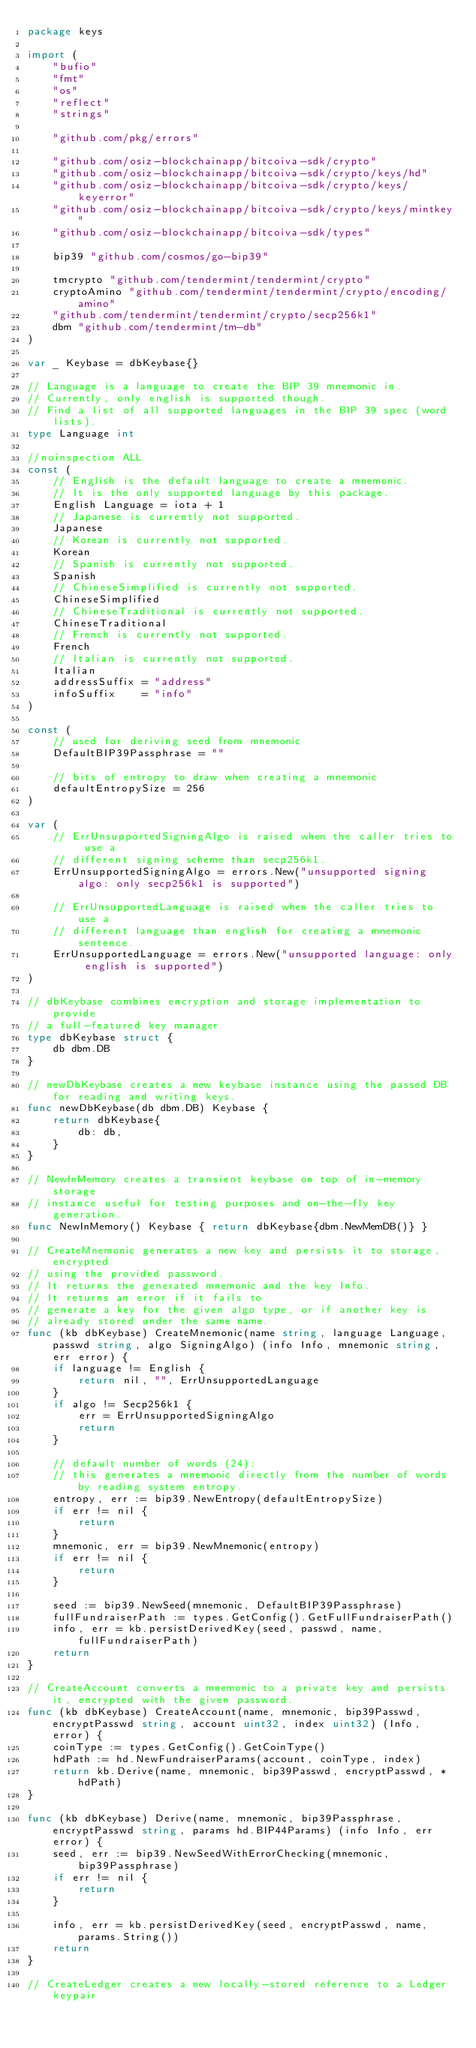<code> <loc_0><loc_0><loc_500><loc_500><_Go_>package keys

import (
	"bufio"
	"fmt"
	"os"
	"reflect"
	"strings"

	"github.com/pkg/errors"

	"github.com/osiz-blockchainapp/bitcoiva-sdk/crypto"
	"github.com/osiz-blockchainapp/bitcoiva-sdk/crypto/keys/hd"
	"github.com/osiz-blockchainapp/bitcoiva-sdk/crypto/keys/keyerror"
	"github.com/osiz-blockchainapp/bitcoiva-sdk/crypto/keys/mintkey"
	"github.com/osiz-blockchainapp/bitcoiva-sdk/types"

	bip39 "github.com/cosmos/go-bip39"

	tmcrypto "github.com/tendermint/tendermint/crypto"
	cryptoAmino "github.com/tendermint/tendermint/crypto/encoding/amino"
	"github.com/tendermint/tendermint/crypto/secp256k1"
	dbm "github.com/tendermint/tm-db"
)

var _ Keybase = dbKeybase{}

// Language is a language to create the BIP 39 mnemonic in.
// Currently, only english is supported though.
// Find a list of all supported languages in the BIP 39 spec (word lists).
type Language int

//noinspection ALL
const (
	// English is the default language to create a mnemonic.
	// It is the only supported language by this package.
	English Language = iota + 1
	// Japanese is currently not supported.
	Japanese
	// Korean is currently not supported.
	Korean
	// Spanish is currently not supported.
	Spanish
	// ChineseSimplified is currently not supported.
	ChineseSimplified
	// ChineseTraditional is currently not supported.
	ChineseTraditional
	// French is currently not supported.
	French
	// Italian is currently not supported.
	Italian
	addressSuffix = "address"
	infoSuffix    = "info"
)

const (
	// used for deriving seed from mnemonic
	DefaultBIP39Passphrase = ""

	// bits of entropy to draw when creating a mnemonic
	defaultEntropySize = 256
)

var (
	// ErrUnsupportedSigningAlgo is raised when the caller tries to use a
	// different signing scheme than secp256k1.
	ErrUnsupportedSigningAlgo = errors.New("unsupported signing algo: only secp256k1 is supported")

	// ErrUnsupportedLanguage is raised when the caller tries to use a
	// different language than english for creating a mnemonic sentence.
	ErrUnsupportedLanguage = errors.New("unsupported language: only english is supported")
)

// dbKeybase combines encryption and storage implementation to provide
// a full-featured key manager
type dbKeybase struct {
	db dbm.DB
}

// newDbKeybase creates a new keybase instance using the passed DB for reading and writing keys.
func newDbKeybase(db dbm.DB) Keybase {
	return dbKeybase{
		db: db,
	}
}

// NewInMemory creates a transient keybase on top of in-memory storage
// instance useful for testing purposes and on-the-fly key generation.
func NewInMemory() Keybase { return dbKeybase{dbm.NewMemDB()} }

// CreateMnemonic generates a new key and persists it to storage, encrypted
// using the provided password.
// It returns the generated mnemonic and the key Info.
// It returns an error if it fails to
// generate a key for the given algo type, or if another key is
// already stored under the same name.
func (kb dbKeybase) CreateMnemonic(name string, language Language, passwd string, algo SigningAlgo) (info Info, mnemonic string, err error) {
	if language != English {
		return nil, "", ErrUnsupportedLanguage
	}
	if algo != Secp256k1 {
		err = ErrUnsupportedSigningAlgo
		return
	}

	// default number of words (24):
	// this generates a mnemonic directly from the number of words by reading system entropy.
	entropy, err := bip39.NewEntropy(defaultEntropySize)
	if err != nil {
		return
	}
	mnemonic, err = bip39.NewMnemonic(entropy)
	if err != nil {
		return
	}

	seed := bip39.NewSeed(mnemonic, DefaultBIP39Passphrase)
	fullFundraiserPath := types.GetConfig().GetFullFundraiserPath()
	info, err = kb.persistDerivedKey(seed, passwd, name, fullFundraiserPath)
	return
}

// CreateAccount converts a mnemonic to a private key and persists it, encrypted with the given password.
func (kb dbKeybase) CreateAccount(name, mnemonic, bip39Passwd, encryptPasswd string, account uint32, index uint32) (Info, error) {
	coinType := types.GetConfig().GetCoinType()
	hdPath := hd.NewFundraiserParams(account, coinType, index)
	return kb.Derive(name, mnemonic, bip39Passwd, encryptPasswd, *hdPath)
}

func (kb dbKeybase) Derive(name, mnemonic, bip39Passphrase, encryptPasswd string, params hd.BIP44Params) (info Info, err error) {
	seed, err := bip39.NewSeedWithErrorChecking(mnemonic, bip39Passphrase)
	if err != nil {
		return
	}

	info, err = kb.persistDerivedKey(seed, encryptPasswd, name, params.String())
	return
}

// CreateLedger creates a new locally-stored reference to a Ledger keypair</code> 